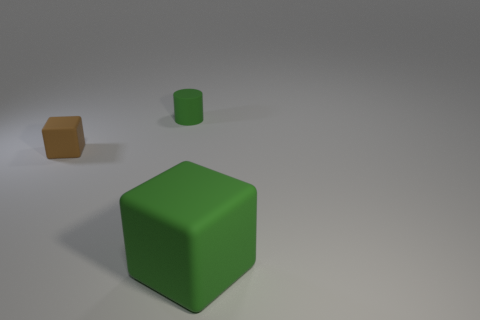What number of objects are made of the same material as the tiny green cylinder?
Provide a succinct answer. 2. The tiny cylinder that is made of the same material as the brown cube is what color?
Your answer should be compact. Green. The brown thing has what shape?
Ensure brevity in your answer.  Cube. There is a block that is behind the big green cube; what is it made of?
Keep it short and to the point. Rubber. Are there any tiny matte objects of the same color as the big matte thing?
Offer a terse response. Yes. The green rubber object that is the same size as the brown matte cube is what shape?
Provide a succinct answer. Cylinder. There is a matte cube to the left of the large green rubber cube; what color is it?
Your answer should be very brief. Brown. Are there any tiny green rubber cylinders behind the rubber thing to the right of the tiny cylinder?
Your response must be concise. Yes. What number of objects are either matte objects that are left of the rubber cylinder or green rubber objects?
Offer a very short reply. 3. Are there any other things that are the same size as the green rubber block?
Offer a terse response. No. 